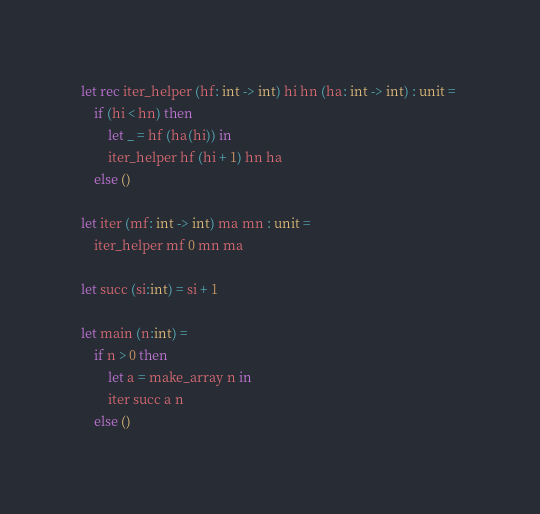Convert code to text. <code><loc_0><loc_0><loc_500><loc_500><_OCaml_>let rec iter_helper (hf: int -> int) hi hn (ha: int -> int) : unit = 
	if (hi < hn) then
		let _ = hf (ha(hi)) in
		iter_helper hf (hi + 1) hn ha
	else ()

let iter (mf: int -> int) ma mn : unit =
	iter_helper mf 0 mn ma

let succ (si:int) = si + 1

let main (n:int) =
	if n > 0 then
		let a = make_array n in
		iter succ a n
	else ()</code> 